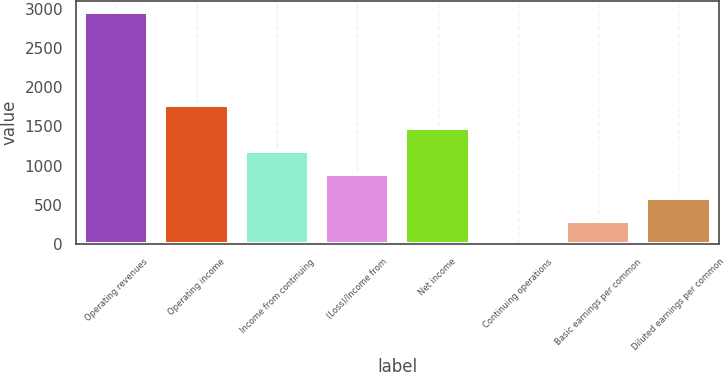Convert chart to OTSL. <chart><loc_0><loc_0><loc_500><loc_500><bar_chart><fcel>Operating revenues<fcel>Operating income<fcel>Income from continuing<fcel>(Loss)/Income from<fcel>Net income<fcel>Continuing operations<fcel>Basic earnings per common<fcel>Diluted earnings per common<nl><fcel>2957<fcel>1774.41<fcel>1183.13<fcel>887.49<fcel>1478.77<fcel>0.57<fcel>296.21<fcel>591.85<nl></chart> 